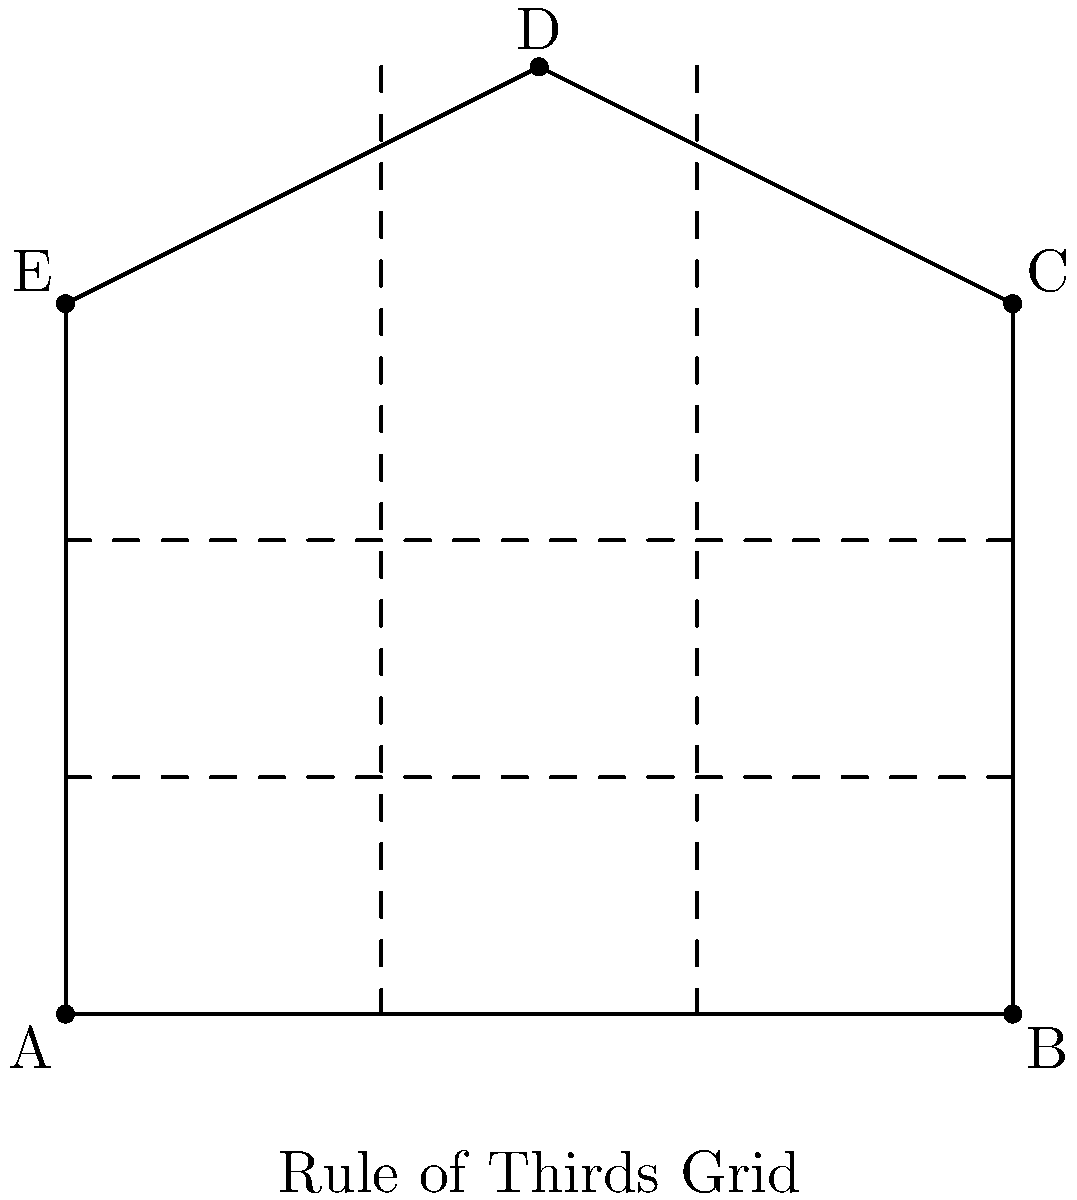In Sam Mendes' film compositions, he often adheres to the Rule of Thirds for visual balance. Consider the above diagram representing a film frame with key visual elements plotted on a Rule of Thirds grid. The points A(0,0), B(8,0), C(8,6), D(4,8), and E(0,6) represent significant visual elements in the composition. Calculate the area of the polygon ABCDE formed by connecting these elements. Round your answer to the nearest whole number. To calculate the area of the irregular polygon ABCDE, we can use the Shoelace formula (also known as the surveyor's formula). The steps are as follows:

1) The Shoelace formula for a polygon with vertices $(x_1, y_1), (x_2, y_2), ..., (x_n, y_n)$ is:

   Area = $\frac{1}{2}|((x_1y_2 + x_2y_3 + ... + x_ny_1) - (y_1x_2 + y_2x_3 + ... + y_nx_1))|$

2) For our polygon ABCDE, we have:
   A(0,0), B(8,0), C(8,6), D(4,8), E(0,6)

3) Applying the formula:

   Area = $\frac{1}{2}|((0 \cdot 0 + 8 \cdot 6 + 8 \cdot 8 + 4 \cdot 6 + 0 \cdot 0) - (0 \cdot 8 + 0 \cdot 8 + 6 \cdot 4 + 8 \cdot 0 + 6 \cdot 0))|$

4) Simplifying:
   
   Area = $\frac{1}{2}|((0 + 48 + 64 + 24 + 0) - (0 + 0 + 24 + 0 + 0))|$
   
   Area = $\frac{1}{2}|(136 - 24)|$
   
   Area = $\frac{1}{2}(112)$
   
   Area = 56

5) The question asks to round to the nearest whole number, but 56 is already a whole number.

Therefore, the area of the polygon ABCDE is 56 square units.
Answer: 56 square units 